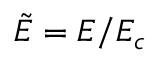<formula> <loc_0><loc_0><loc_500><loc_500>\tilde { E } = E / E _ { c }</formula> 